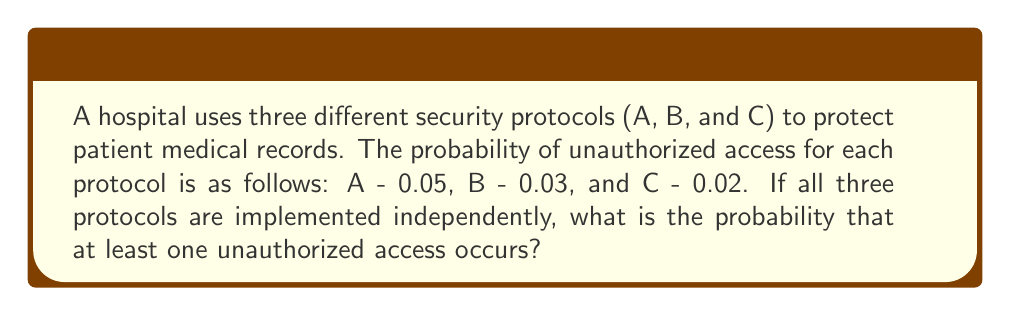Can you answer this question? To solve this problem, we'll use the concept of probability of the complement event.

Step 1: Calculate the probability that no unauthorized access occurs for each protocol.
Protocol A: $P(A) = 1 - 0.05 = 0.95$
Protocol B: $P(B) = 1 - 0.03 = 0.97$
Protocol C: $P(C) = 1 - 0.02 = 0.98$

Step 2: Calculate the probability that no unauthorized access occurs for all protocols.
Since the protocols are independent, we multiply the individual probabilities:
$P(\text{no access}) = P(A) \times P(B) \times P(C) = 0.95 \times 0.97 \times 0.98 = 0.903070$

Step 3: Calculate the probability of at least one unauthorized access.
This is the complement of the probability that no unauthorized access occurs:
$P(\text{at least one access}) = 1 - P(\text{no access}) = 1 - 0.903070 = 0.096930$

Step 4: Convert to a percentage.
$0.096930 \times 100\% = 9.693\%$
Answer: 9.693% 